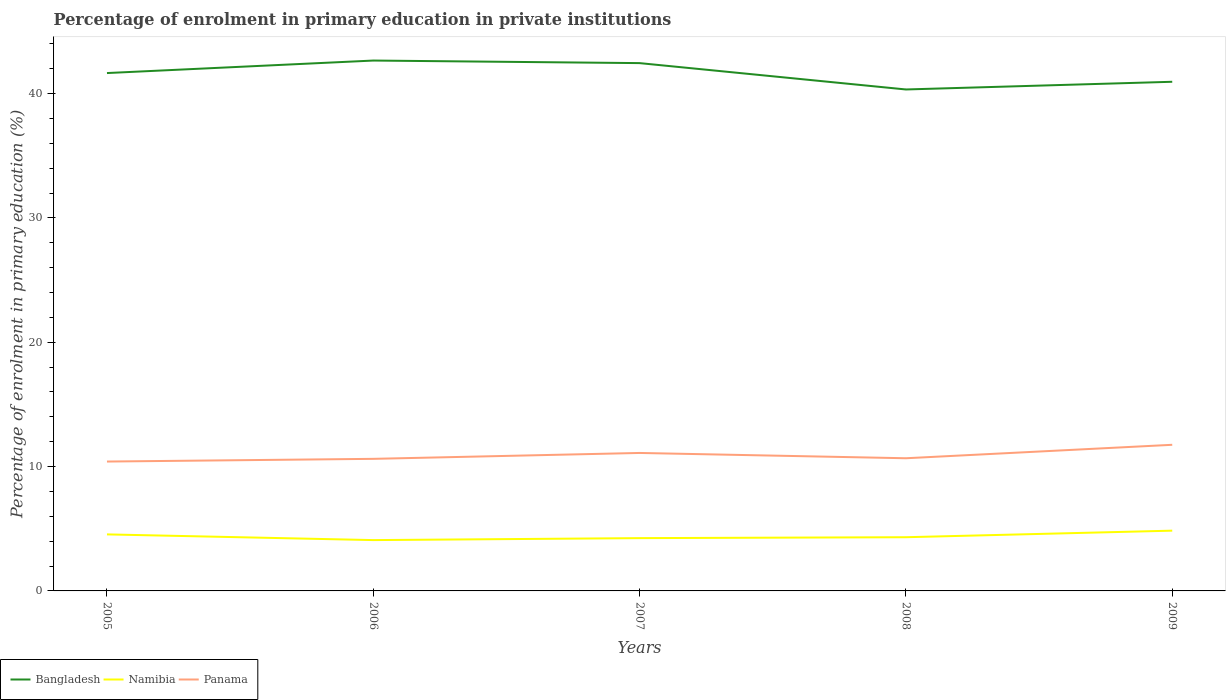Is the number of lines equal to the number of legend labels?
Provide a short and direct response. Yes. Across all years, what is the maximum percentage of enrolment in primary education in Panama?
Make the answer very short. 10.41. What is the total percentage of enrolment in primary education in Bangladesh in the graph?
Ensure brevity in your answer.  2.33. What is the difference between the highest and the second highest percentage of enrolment in primary education in Panama?
Offer a very short reply. 1.35. How many lines are there?
Keep it short and to the point. 3. What is the difference between two consecutive major ticks on the Y-axis?
Give a very brief answer. 10. What is the title of the graph?
Offer a terse response. Percentage of enrolment in primary education in private institutions. What is the label or title of the X-axis?
Your answer should be very brief. Years. What is the label or title of the Y-axis?
Your answer should be very brief. Percentage of enrolment in primary education (%). What is the Percentage of enrolment in primary education (%) of Bangladesh in 2005?
Provide a short and direct response. 41.65. What is the Percentage of enrolment in primary education (%) of Namibia in 2005?
Your answer should be very brief. 4.55. What is the Percentage of enrolment in primary education (%) in Panama in 2005?
Your response must be concise. 10.41. What is the Percentage of enrolment in primary education (%) in Bangladesh in 2006?
Provide a succinct answer. 42.66. What is the Percentage of enrolment in primary education (%) of Namibia in 2006?
Your response must be concise. 4.09. What is the Percentage of enrolment in primary education (%) in Panama in 2006?
Provide a short and direct response. 10.62. What is the Percentage of enrolment in primary education (%) in Bangladesh in 2007?
Provide a succinct answer. 42.45. What is the Percentage of enrolment in primary education (%) in Namibia in 2007?
Your answer should be compact. 4.25. What is the Percentage of enrolment in primary education (%) in Panama in 2007?
Your answer should be very brief. 11.1. What is the Percentage of enrolment in primary education (%) in Bangladesh in 2008?
Keep it short and to the point. 40.33. What is the Percentage of enrolment in primary education (%) in Namibia in 2008?
Your answer should be very brief. 4.32. What is the Percentage of enrolment in primary education (%) in Panama in 2008?
Offer a very short reply. 10.67. What is the Percentage of enrolment in primary education (%) of Bangladesh in 2009?
Your response must be concise. 40.95. What is the Percentage of enrolment in primary education (%) in Namibia in 2009?
Ensure brevity in your answer.  4.85. What is the Percentage of enrolment in primary education (%) in Panama in 2009?
Your answer should be compact. 11.75. Across all years, what is the maximum Percentage of enrolment in primary education (%) in Bangladesh?
Offer a terse response. 42.66. Across all years, what is the maximum Percentage of enrolment in primary education (%) of Namibia?
Your response must be concise. 4.85. Across all years, what is the maximum Percentage of enrolment in primary education (%) in Panama?
Ensure brevity in your answer.  11.75. Across all years, what is the minimum Percentage of enrolment in primary education (%) of Bangladesh?
Offer a terse response. 40.33. Across all years, what is the minimum Percentage of enrolment in primary education (%) in Namibia?
Offer a very short reply. 4.09. Across all years, what is the minimum Percentage of enrolment in primary education (%) of Panama?
Provide a succinct answer. 10.41. What is the total Percentage of enrolment in primary education (%) of Bangladesh in the graph?
Your response must be concise. 208.04. What is the total Percentage of enrolment in primary education (%) in Namibia in the graph?
Ensure brevity in your answer.  22.05. What is the total Percentage of enrolment in primary education (%) of Panama in the graph?
Keep it short and to the point. 54.55. What is the difference between the Percentage of enrolment in primary education (%) in Bangladesh in 2005 and that in 2006?
Provide a succinct answer. -1.01. What is the difference between the Percentage of enrolment in primary education (%) in Namibia in 2005 and that in 2006?
Give a very brief answer. 0.46. What is the difference between the Percentage of enrolment in primary education (%) in Panama in 2005 and that in 2006?
Give a very brief answer. -0.22. What is the difference between the Percentage of enrolment in primary education (%) in Bangladesh in 2005 and that in 2007?
Give a very brief answer. -0.8. What is the difference between the Percentage of enrolment in primary education (%) in Namibia in 2005 and that in 2007?
Keep it short and to the point. 0.3. What is the difference between the Percentage of enrolment in primary education (%) in Panama in 2005 and that in 2007?
Provide a succinct answer. -0.69. What is the difference between the Percentage of enrolment in primary education (%) in Bangladesh in 2005 and that in 2008?
Ensure brevity in your answer.  1.32. What is the difference between the Percentage of enrolment in primary education (%) in Namibia in 2005 and that in 2008?
Make the answer very short. 0.23. What is the difference between the Percentage of enrolment in primary education (%) of Panama in 2005 and that in 2008?
Your response must be concise. -0.26. What is the difference between the Percentage of enrolment in primary education (%) of Bangladesh in 2005 and that in 2009?
Offer a terse response. 0.7. What is the difference between the Percentage of enrolment in primary education (%) in Namibia in 2005 and that in 2009?
Keep it short and to the point. -0.3. What is the difference between the Percentage of enrolment in primary education (%) of Panama in 2005 and that in 2009?
Offer a very short reply. -1.35. What is the difference between the Percentage of enrolment in primary education (%) in Bangladesh in 2006 and that in 2007?
Make the answer very short. 0.21. What is the difference between the Percentage of enrolment in primary education (%) of Namibia in 2006 and that in 2007?
Provide a short and direct response. -0.16. What is the difference between the Percentage of enrolment in primary education (%) of Panama in 2006 and that in 2007?
Offer a terse response. -0.47. What is the difference between the Percentage of enrolment in primary education (%) in Bangladesh in 2006 and that in 2008?
Your response must be concise. 2.33. What is the difference between the Percentage of enrolment in primary education (%) of Namibia in 2006 and that in 2008?
Keep it short and to the point. -0.23. What is the difference between the Percentage of enrolment in primary education (%) in Panama in 2006 and that in 2008?
Provide a short and direct response. -0.05. What is the difference between the Percentage of enrolment in primary education (%) of Bangladesh in 2006 and that in 2009?
Make the answer very short. 1.71. What is the difference between the Percentage of enrolment in primary education (%) in Namibia in 2006 and that in 2009?
Give a very brief answer. -0.76. What is the difference between the Percentage of enrolment in primary education (%) in Panama in 2006 and that in 2009?
Make the answer very short. -1.13. What is the difference between the Percentage of enrolment in primary education (%) of Bangladesh in 2007 and that in 2008?
Ensure brevity in your answer.  2.12. What is the difference between the Percentage of enrolment in primary education (%) of Namibia in 2007 and that in 2008?
Ensure brevity in your answer.  -0.07. What is the difference between the Percentage of enrolment in primary education (%) of Panama in 2007 and that in 2008?
Provide a succinct answer. 0.43. What is the difference between the Percentage of enrolment in primary education (%) in Bangladesh in 2007 and that in 2009?
Your answer should be compact. 1.5. What is the difference between the Percentage of enrolment in primary education (%) of Namibia in 2007 and that in 2009?
Ensure brevity in your answer.  -0.6. What is the difference between the Percentage of enrolment in primary education (%) of Panama in 2007 and that in 2009?
Keep it short and to the point. -0.66. What is the difference between the Percentage of enrolment in primary education (%) of Bangladesh in 2008 and that in 2009?
Keep it short and to the point. -0.62. What is the difference between the Percentage of enrolment in primary education (%) in Namibia in 2008 and that in 2009?
Offer a terse response. -0.53. What is the difference between the Percentage of enrolment in primary education (%) of Panama in 2008 and that in 2009?
Keep it short and to the point. -1.08. What is the difference between the Percentage of enrolment in primary education (%) of Bangladesh in 2005 and the Percentage of enrolment in primary education (%) of Namibia in 2006?
Your answer should be very brief. 37.56. What is the difference between the Percentage of enrolment in primary education (%) in Bangladesh in 2005 and the Percentage of enrolment in primary education (%) in Panama in 2006?
Your answer should be compact. 31.03. What is the difference between the Percentage of enrolment in primary education (%) of Namibia in 2005 and the Percentage of enrolment in primary education (%) of Panama in 2006?
Provide a succinct answer. -6.08. What is the difference between the Percentage of enrolment in primary education (%) of Bangladesh in 2005 and the Percentage of enrolment in primary education (%) of Namibia in 2007?
Offer a terse response. 37.41. What is the difference between the Percentage of enrolment in primary education (%) in Bangladesh in 2005 and the Percentage of enrolment in primary education (%) in Panama in 2007?
Ensure brevity in your answer.  30.55. What is the difference between the Percentage of enrolment in primary education (%) of Namibia in 2005 and the Percentage of enrolment in primary education (%) of Panama in 2007?
Your answer should be very brief. -6.55. What is the difference between the Percentage of enrolment in primary education (%) of Bangladesh in 2005 and the Percentage of enrolment in primary education (%) of Namibia in 2008?
Make the answer very short. 37.33. What is the difference between the Percentage of enrolment in primary education (%) in Bangladesh in 2005 and the Percentage of enrolment in primary education (%) in Panama in 2008?
Provide a succinct answer. 30.98. What is the difference between the Percentage of enrolment in primary education (%) of Namibia in 2005 and the Percentage of enrolment in primary education (%) of Panama in 2008?
Ensure brevity in your answer.  -6.12. What is the difference between the Percentage of enrolment in primary education (%) in Bangladesh in 2005 and the Percentage of enrolment in primary education (%) in Namibia in 2009?
Offer a terse response. 36.8. What is the difference between the Percentage of enrolment in primary education (%) in Bangladesh in 2005 and the Percentage of enrolment in primary education (%) in Panama in 2009?
Offer a very short reply. 29.9. What is the difference between the Percentage of enrolment in primary education (%) in Namibia in 2005 and the Percentage of enrolment in primary education (%) in Panama in 2009?
Offer a very short reply. -7.21. What is the difference between the Percentage of enrolment in primary education (%) in Bangladesh in 2006 and the Percentage of enrolment in primary education (%) in Namibia in 2007?
Your answer should be compact. 38.41. What is the difference between the Percentage of enrolment in primary education (%) in Bangladesh in 2006 and the Percentage of enrolment in primary education (%) in Panama in 2007?
Your response must be concise. 31.56. What is the difference between the Percentage of enrolment in primary education (%) of Namibia in 2006 and the Percentage of enrolment in primary education (%) of Panama in 2007?
Your answer should be compact. -7.01. What is the difference between the Percentage of enrolment in primary education (%) of Bangladesh in 2006 and the Percentage of enrolment in primary education (%) of Namibia in 2008?
Offer a very short reply. 38.34. What is the difference between the Percentage of enrolment in primary education (%) in Bangladesh in 2006 and the Percentage of enrolment in primary education (%) in Panama in 2008?
Make the answer very short. 31.99. What is the difference between the Percentage of enrolment in primary education (%) of Namibia in 2006 and the Percentage of enrolment in primary education (%) of Panama in 2008?
Your answer should be very brief. -6.58. What is the difference between the Percentage of enrolment in primary education (%) of Bangladesh in 2006 and the Percentage of enrolment in primary education (%) of Namibia in 2009?
Provide a short and direct response. 37.81. What is the difference between the Percentage of enrolment in primary education (%) in Bangladesh in 2006 and the Percentage of enrolment in primary education (%) in Panama in 2009?
Give a very brief answer. 30.91. What is the difference between the Percentage of enrolment in primary education (%) of Namibia in 2006 and the Percentage of enrolment in primary education (%) of Panama in 2009?
Make the answer very short. -7.66. What is the difference between the Percentage of enrolment in primary education (%) in Bangladesh in 2007 and the Percentage of enrolment in primary education (%) in Namibia in 2008?
Provide a short and direct response. 38.13. What is the difference between the Percentage of enrolment in primary education (%) in Bangladesh in 2007 and the Percentage of enrolment in primary education (%) in Panama in 2008?
Your answer should be very brief. 31.78. What is the difference between the Percentage of enrolment in primary education (%) in Namibia in 2007 and the Percentage of enrolment in primary education (%) in Panama in 2008?
Make the answer very short. -6.42. What is the difference between the Percentage of enrolment in primary education (%) in Bangladesh in 2007 and the Percentage of enrolment in primary education (%) in Namibia in 2009?
Keep it short and to the point. 37.6. What is the difference between the Percentage of enrolment in primary education (%) in Bangladesh in 2007 and the Percentage of enrolment in primary education (%) in Panama in 2009?
Keep it short and to the point. 30.7. What is the difference between the Percentage of enrolment in primary education (%) of Namibia in 2007 and the Percentage of enrolment in primary education (%) of Panama in 2009?
Provide a succinct answer. -7.51. What is the difference between the Percentage of enrolment in primary education (%) in Bangladesh in 2008 and the Percentage of enrolment in primary education (%) in Namibia in 2009?
Keep it short and to the point. 35.48. What is the difference between the Percentage of enrolment in primary education (%) of Bangladesh in 2008 and the Percentage of enrolment in primary education (%) of Panama in 2009?
Provide a short and direct response. 28.58. What is the difference between the Percentage of enrolment in primary education (%) of Namibia in 2008 and the Percentage of enrolment in primary education (%) of Panama in 2009?
Make the answer very short. -7.43. What is the average Percentage of enrolment in primary education (%) in Bangladesh per year?
Your response must be concise. 41.61. What is the average Percentage of enrolment in primary education (%) of Namibia per year?
Provide a succinct answer. 4.41. What is the average Percentage of enrolment in primary education (%) in Panama per year?
Offer a terse response. 10.91. In the year 2005, what is the difference between the Percentage of enrolment in primary education (%) in Bangladesh and Percentage of enrolment in primary education (%) in Namibia?
Your response must be concise. 37.11. In the year 2005, what is the difference between the Percentage of enrolment in primary education (%) of Bangladesh and Percentage of enrolment in primary education (%) of Panama?
Provide a short and direct response. 31.25. In the year 2005, what is the difference between the Percentage of enrolment in primary education (%) of Namibia and Percentage of enrolment in primary education (%) of Panama?
Ensure brevity in your answer.  -5.86. In the year 2006, what is the difference between the Percentage of enrolment in primary education (%) of Bangladesh and Percentage of enrolment in primary education (%) of Namibia?
Provide a short and direct response. 38.57. In the year 2006, what is the difference between the Percentage of enrolment in primary education (%) of Bangladesh and Percentage of enrolment in primary education (%) of Panama?
Make the answer very short. 32.03. In the year 2006, what is the difference between the Percentage of enrolment in primary education (%) of Namibia and Percentage of enrolment in primary education (%) of Panama?
Your answer should be very brief. -6.53. In the year 2007, what is the difference between the Percentage of enrolment in primary education (%) in Bangladesh and Percentage of enrolment in primary education (%) in Namibia?
Keep it short and to the point. 38.2. In the year 2007, what is the difference between the Percentage of enrolment in primary education (%) of Bangladesh and Percentage of enrolment in primary education (%) of Panama?
Offer a terse response. 31.35. In the year 2007, what is the difference between the Percentage of enrolment in primary education (%) in Namibia and Percentage of enrolment in primary education (%) in Panama?
Provide a short and direct response. -6.85. In the year 2008, what is the difference between the Percentage of enrolment in primary education (%) in Bangladesh and Percentage of enrolment in primary education (%) in Namibia?
Ensure brevity in your answer.  36.01. In the year 2008, what is the difference between the Percentage of enrolment in primary education (%) in Bangladesh and Percentage of enrolment in primary education (%) in Panama?
Offer a very short reply. 29.66. In the year 2008, what is the difference between the Percentage of enrolment in primary education (%) of Namibia and Percentage of enrolment in primary education (%) of Panama?
Your response must be concise. -6.35. In the year 2009, what is the difference between the Percentage of enrolment in primary education (%) in Bangladesh and Percentage of enrolment in primary education (%) in Namibia?
Keep it short and to the point. 36.1. In the year 2009, what is the difference between the Percentage of enrolment in primary education (%) of Bangladesh and Percentage of enrolment in primary education (%) of Panama?
Your response must be concise. 29.2. In the year 2009, what is the difference between the Percentage of enrolment in primary education (%) in Namibia and Percentage of enrolment in primary education (%) in Panama?
Give a very brief answer. -6.9. What is the ratio of the Percentage of enrolment in primary education (%) in Bangladesh in 2005 to that in 2006?
Keep it short and to the point. 0.98. What is the ratio of the Percentage of enrolment in primary education (%) in Namibia in 2005 to that in 2006?
Keep it short and to the point. 1.11. What is the ratio of the Percentage of enrolment in primary education (%) of Panama in 2005 to that in 2006?
Your answer should be very brief. 0.98. What is the ratio of the Percentage of enrolment in primary education (%) of Bangladesh in 2005 to that in 2007?
Offer a terse response. 0.98. What is the ratio of the Percentage of enrolment in primary education (%) of Namibia in 2005 to that in 2007?
Give a very brief answer. 1.07. What is the ratio of the Percentage of enrolment in primary education (%) in Panama in 2005 to that in 2007?
Keep it short and to the point. 0.94. What is the ratio of the Percentage of enrolment in primary education (%) in Bangladesh in 2005 to that in 2008?
Provide a short and direct response. 1.03. What is the ratio of the Percentage of enrolment in primary education (%) in Namibia in 2005 to that in 2008?
Your response must be concise. 1.05. What is the ratio of the Percentage of enrolment in primary education (%) in Panama in 2005 to that in 2008?
Your response must be concise. 0.98. What is the ratio of the Percentage of enrolment in primary education (%) in Bangladesh in 2005 to that in 2009?
Your response must be concise. 1.02. What is the ratio of the Percentage of enrolment in primary education (%) in Namibia in 2005 to that in 2009?
Your answer should be very brief. 0.94. What is the ratio of the Percentage of enrolment in primary education (%) of Panama in 2005 to that in 2009?
Provide a succinct answer. 0.89. What is the ratio of the Percentage of enrolment in primary education (%) in Bangladesh in 2006 to that in 2007?
Offer a very short reply. 1. What is the ratio of the Percentage of enrolment in primary education (%) in Namibia in 2006 to that in 2007?
Your response must be concise. 0.96. What is the ratio of the Percentage of enrolment in primary education (%) in Panama in 2006 to that in 2007?
Provide a succinct answer. 0.96. What is the ratio of the Percentage of enrolment in primary education (%) in Bangladesh in 2006 to that in 2008?
Your answer should be very brief. 1.06. What is the ratio of the Percentage of enrolment in primary education (%) of Namibia in 2006 to that in 2008?
Give a very brief answer. 0.95. What is the ratio of the Percentage of enrolment in primary education (%) in Bangladesh in 2006 to that in 2009?
Your answer should be very brief. 1.04. What is the ratio of the Percentage of enrolment in primary education (%) of Namibia in 2006 to that in 2009?
Make the answer very short. 0.84. What is the ratio of the Percentage of enrolment in primary education (%) of Panama in 2006 to that in 2009?
Make the answer very short. 0.9. What is the ratio of the Percentage of enrolment in primary education (%) of Bangladesh in 2007 to that in 2008?
Give a very brief answer. 1.05. What is the ratio of the Percentage of enrolment in primary education (%) of Namibia in 2007 to that in 2008?
Offer a very short reply. 0.98. What is the ratio of the Percentage of enrolment in primary education (%) in Panama in 2007 to that in 2008?
Keep it short and to the point. 1.04. What is the ratio of the Percentage of enrolment in primary education (%) of Bangladesh in 2007 to that in 2009?
Keep it short and to the point. 1.04. What is the ratio of the Percentage of enrolment in primary education (%) in Namibia in 2007 to that in 2009?
Your answer should be compact. 0.88. What is the ratio of the Percentage of enrolment in primary education (%) in Panama in 2007 to that in 2009?
Your answer should be very brief. 0.94. What is the ratio of the Percentage of enrolment in primary education (%) of Bangladesh in 2008 to that in 2009?
Provide a succinct answer. 0.98. What is the ratio of the Percentage of enrolment in primary education (%) in Namibia in 2008 to that in 2009?
Make the answer very short. 0.89. What is the ratio of the Percentage of enrolment in primary education (%) of Panama in 2008 to that in 2009?
Offer a terse response. 0.91. What is the difference between the highest and the second highest Percentage of enrolment in primary education (%) in Bangladesh?
Your answer should be very brief. 0.21. What is the difference between the highest and the second highest Percentage of enrolment in primary education (%) of Namibia?
Make the answer very short. 0.3. What is the difference between the highest and the second highest Percentage of enrolment in primary education (%) in Panama?
Keep it short and to the point. 0.66. What is the difference between the highest and the lowest Percentage of enrolment in primary education (%) of Bangladesh?
Give a very brief answer. 2.33. What is the difference between the highest and the lowest Percentage of enrolment in primary education (%) of Namibia?
Give a very brief answer. 0.76. What is the difference between the highest and the lowest Percentage of enrolment in primary education (%) of Panama?
Your response must be concise. 1.35. 